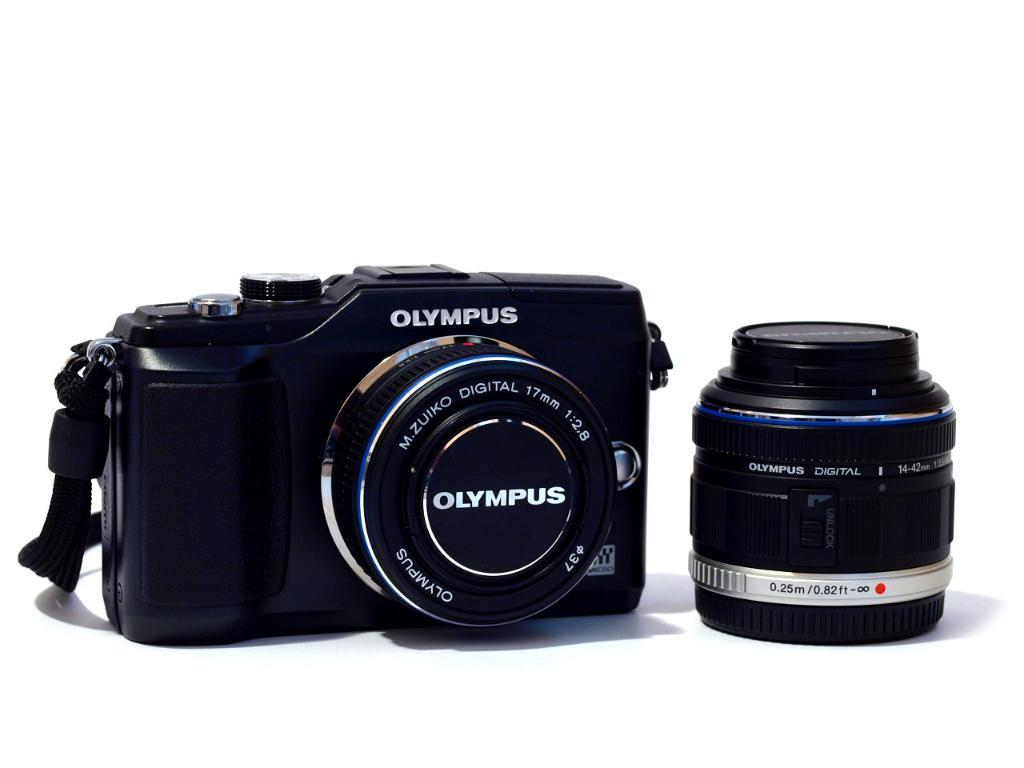<image>
Share a concise interpretation of the image provided. An Olympus camera has the lens cap on it. 